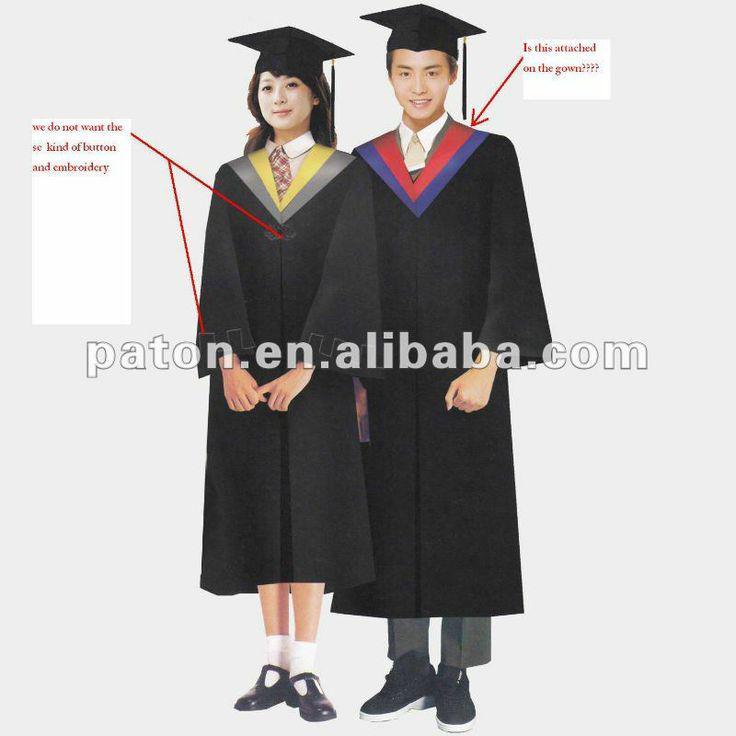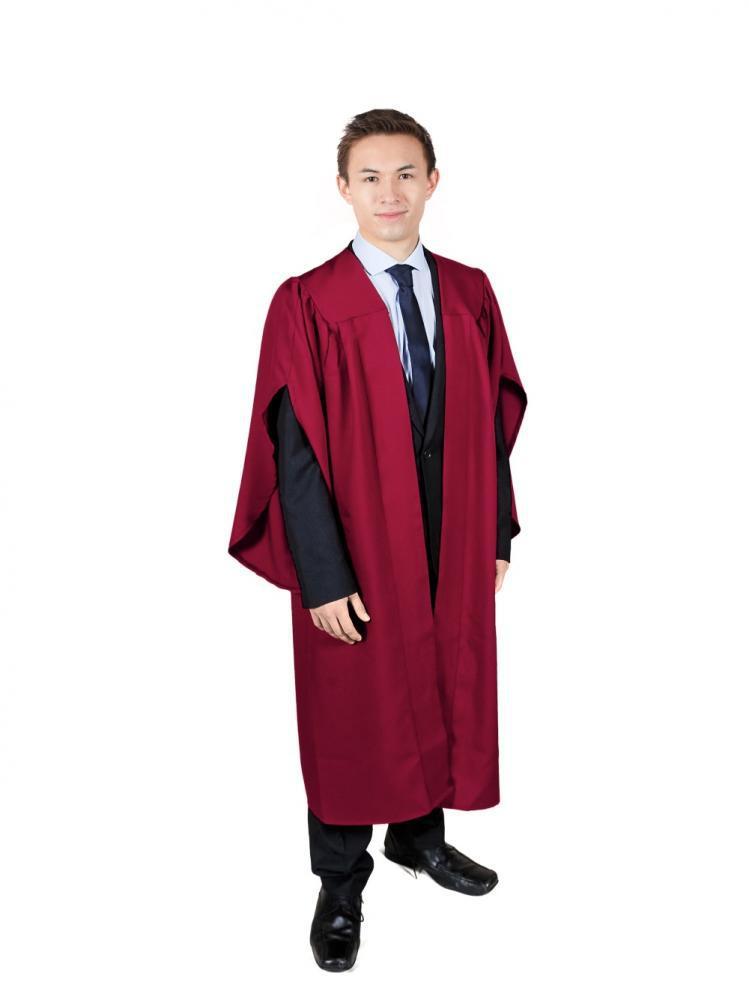The first image is the image on the left, the second image is the image on the right. Evaluate the accuracy of this statement regarding the images: "THere are exactly two people in the image on the left.". Is it true? Answer yes or no. Yes. 